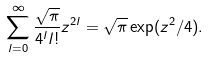Convert formula to latex. <formula><loc_0><loc_0><loc_500><loc_500>\sum _ { l = 0 } ^ { \infty } \frac { \sqrt { \pi } } { 4 ^ { l } l ! } z ^ { 2 l } = \sqrt { \pi } \exp ( z ^ { 2 } / 4 ) .</formula> 